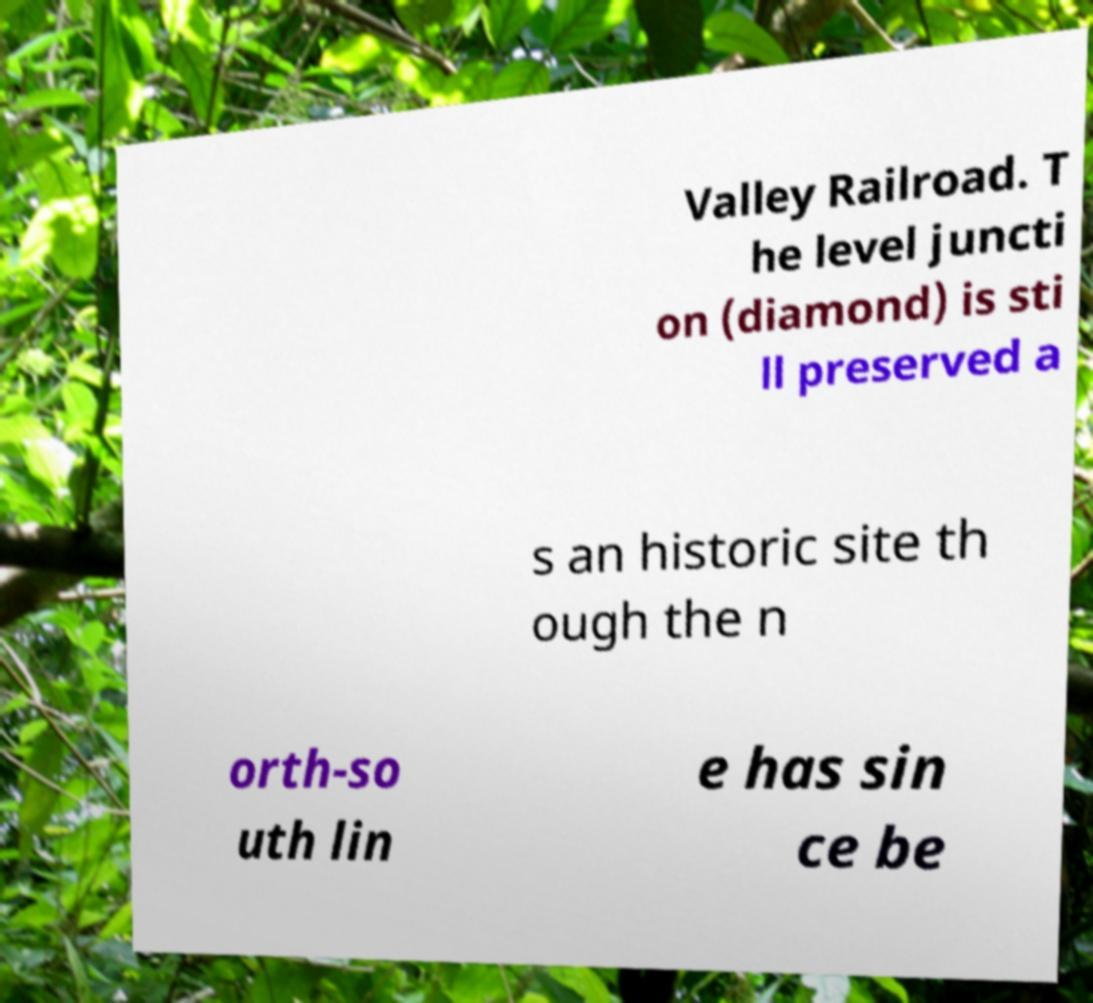Could you extract and type out the text from this image? Valley Railroad. T he level juncti on (diamond) is sti ll preserved a s an historic site th ough the n orth-so uth lin e has sin ce be 